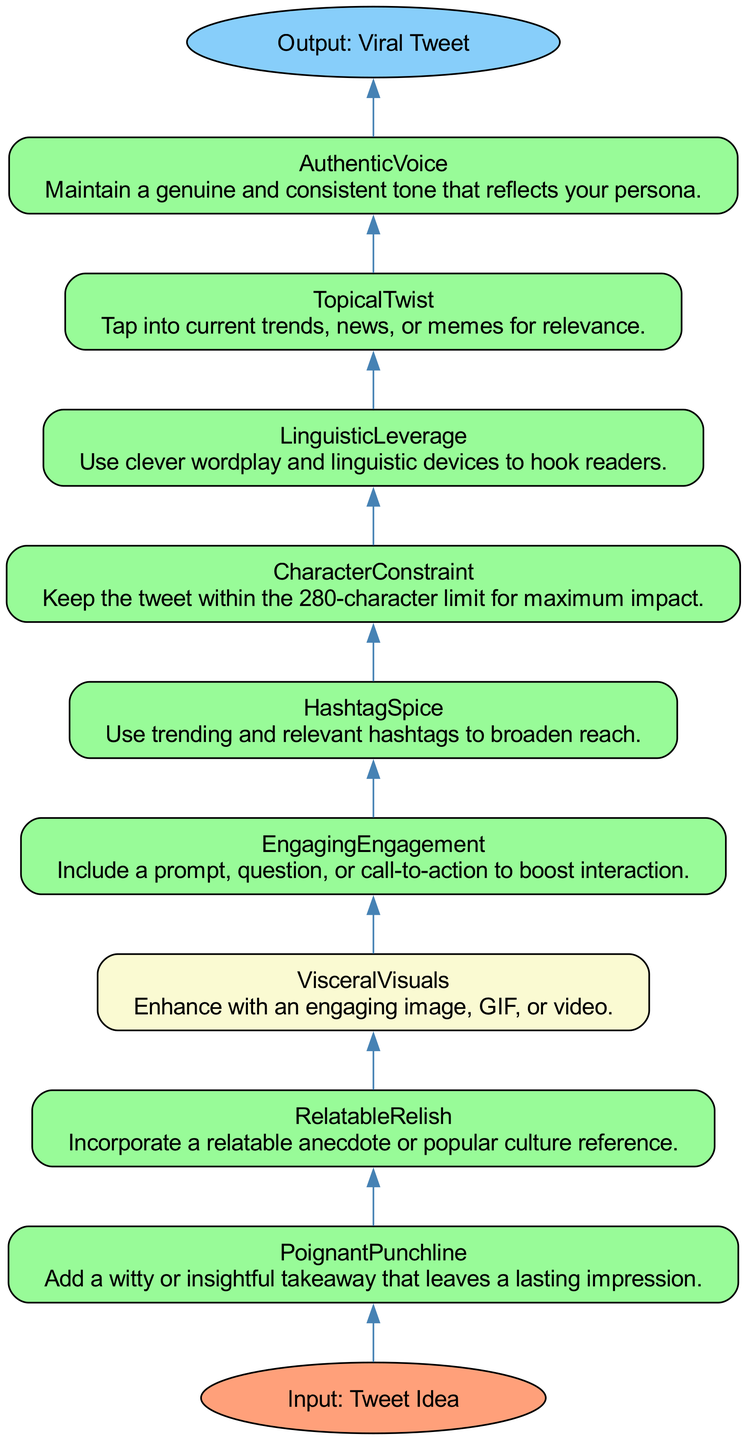What is the output of this diagram? The diagram outlines the process of creating a viral tweet and clearly labels the output as "Viral Tweet."
Answer: Viral Tweet How many process steps are required to create a viral tweet? By counting the individual process steps listed in the diagram, there are a total of 9 required steps for creating a viral tweet.
Answer: 9 What is the first step in the process of creating a viral tweet? The diagram lists the initial step at the bottom as "Authentic Voice," establishing the need for a genuine tone in tweets.
Answer: Authentic Voice Which step incorporates a relatable anecdote? The step that includes a relatable anecdote is labeled "Relatable Relish," indicating the importance of connecting with readers through popular references.
Answer: Relatable Relish Which steps are marked as optional in the process? The diagram highlights "Visceral Visuals" as the only optional step, indicating that engaging images or videos enhance tweets but aren't mandatory.
Answer: Visceral Visuals What is the relationship between "Character Constraint" and "Hashtag Spice"? "Character Constraint," which sets a maximum character limit, precedes "Hashtag Spice," indicating that both are essential components in the tweet creation process.
Answer: Character Constraint comes before Hashtag Spice Which steps must be completed before achieving the output? All steps listed from "Authentic Voice" to "Character Constraint" must be completed before reaching the output of "Viral Tweet," as they are interconnected to achieve the final product.
Answer: All steps prior to output What color represents the required steps in the diagram? The required steps are represented in a shade of green (#98FB98), differentiating them from optional steps, which are in a light yellow (#FAFAD2).
Answer: Green Which step taps into current trends? The step labeled "Topical Twist" is specifically designed to engage with current trends and news, capturing the essence of relevance in tweeting.
Answer: Topical Twist 